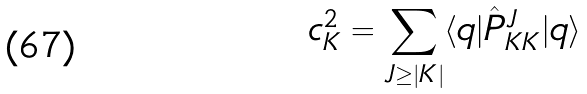Convert formula to latex. <formula><loc_0><loc_0><loc_500><loc_500>c _ { K } ^ { 2 } = \sum _ { J \geq | K | } \langle q | \hat { P } ^ { J } _ { K K } | q \rangle</formula> 